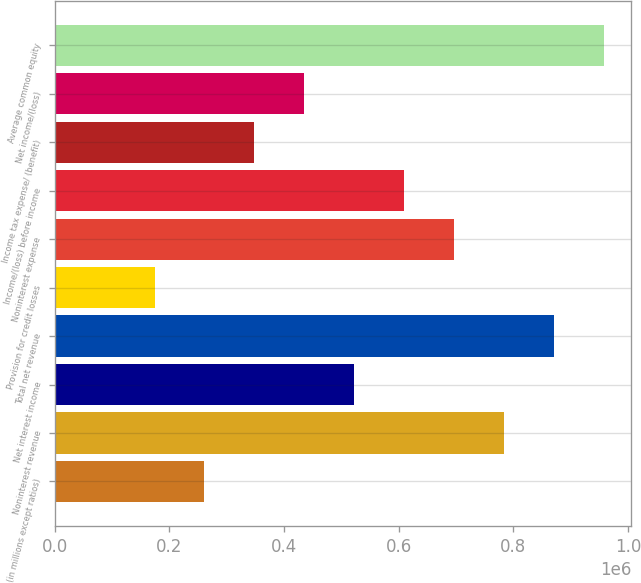Convert chart to OTSL. <chart><loc_0><loc_0><loc_500><loc_500><bar_chart><fcel>(in millions except ratios)<fcel>Noninterest revenue<fcel>Net interest income<fcel>Total net revenue<fcel>Provision for credit losses<fcel>Noninterest expense<fcel>Income/(loss) before income<fcel>Income tax expense/ (benefit)<fcel>Net income/(loss)<fcel>Average common equity<nl><fcel>261201<fcel>783570<fcel>522385<fcel>870631<fcel>174140<fcel>696508<fcel>609447<fcel>348263<fcel>435324<fcel>957692<nl></chart> 